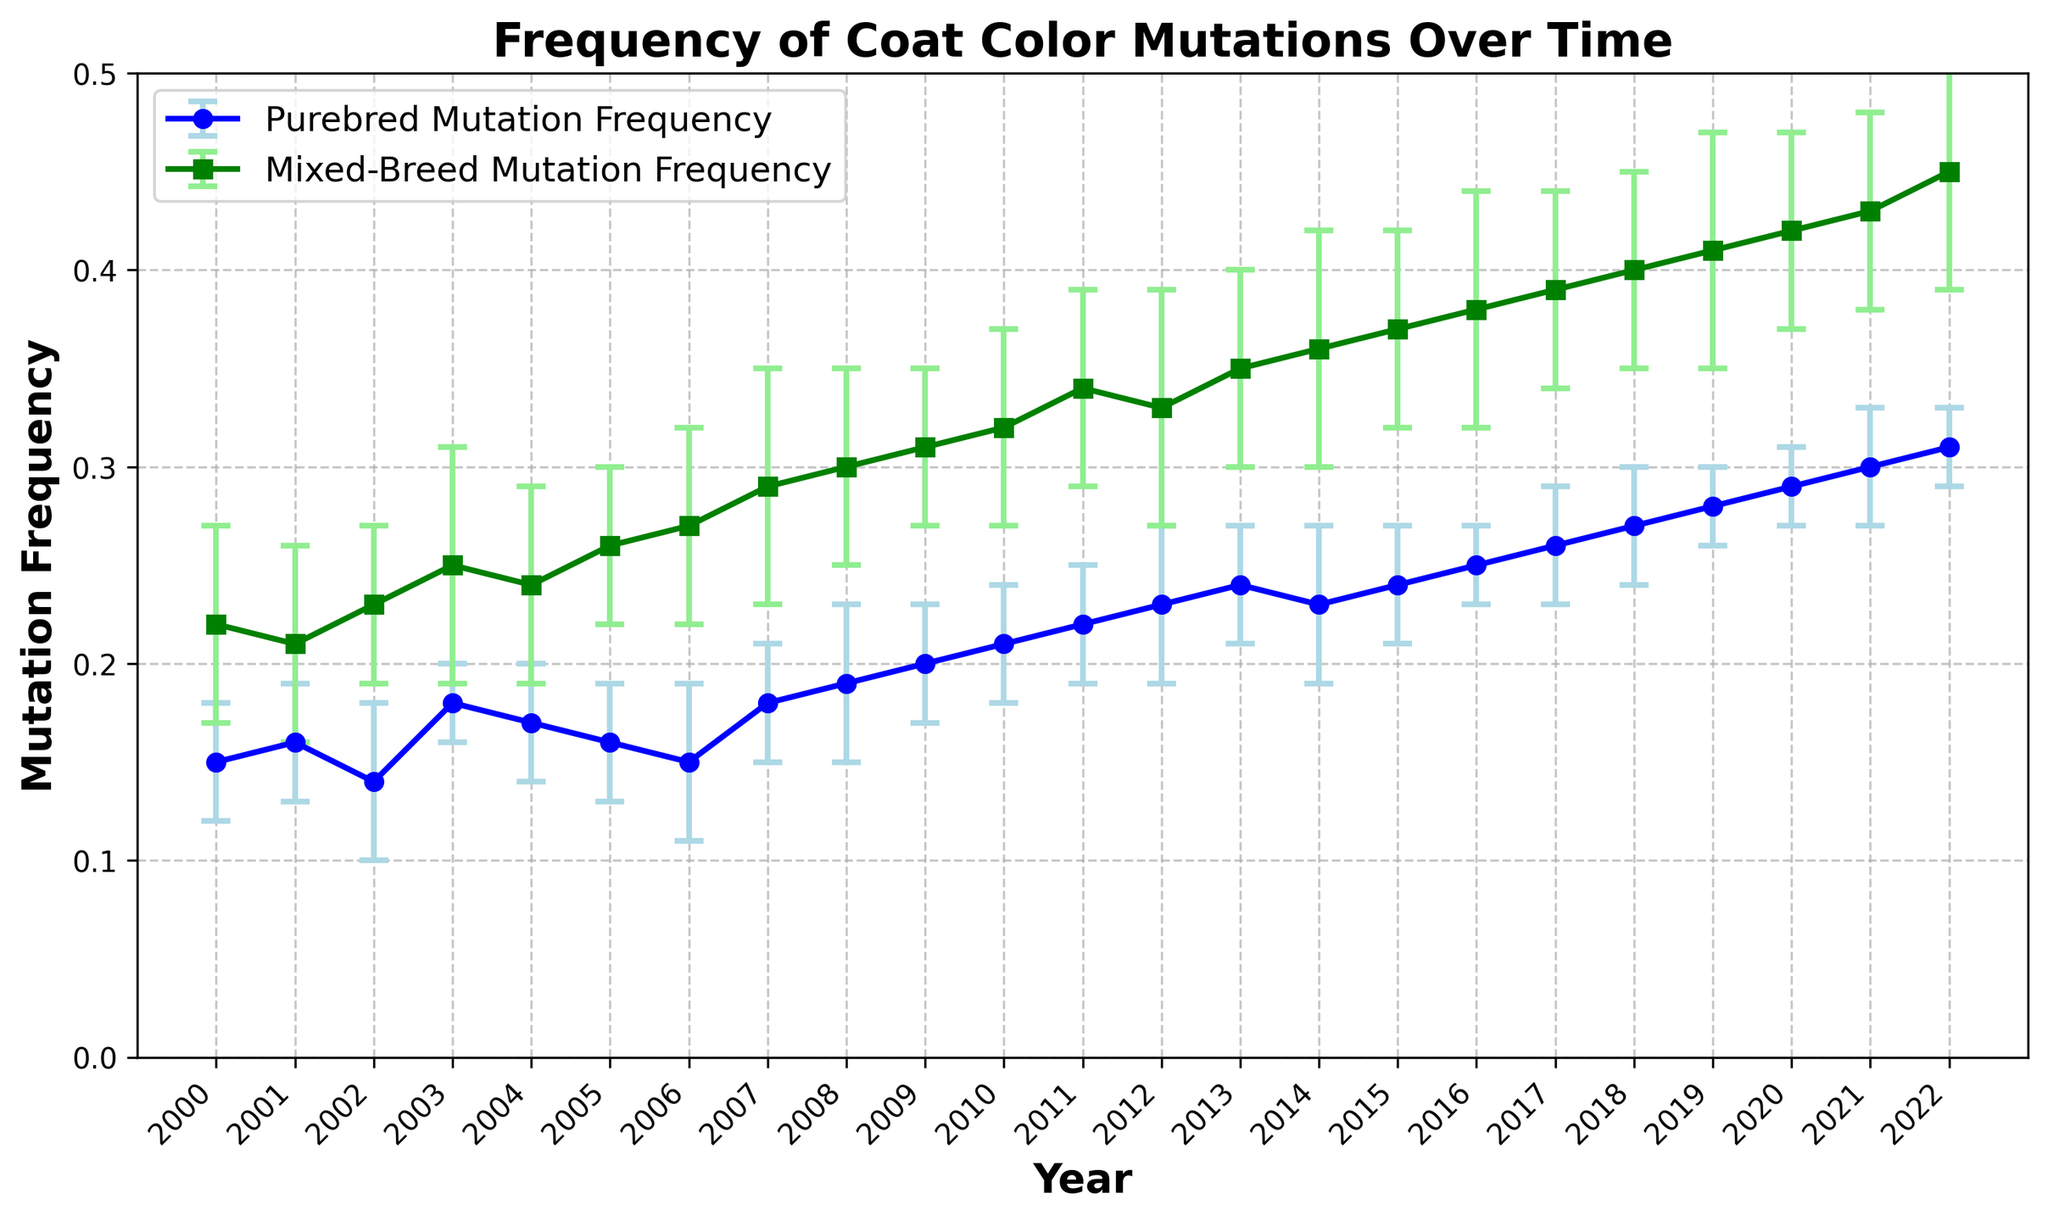What is the difference in mutation frequency between purebred and mixed-breed dogs in the year 2022? To find the difference, subtract the mutation frequency of purebred dogs from that of mixed-breed dogs in 2022: 0.45 - 0.31 = 0.14
Answer: 0.14 Which year shows the highest mutation frequency for purebred dogs, and what is that value? The year with the highest mutation frequency for purebred dogs can be found by examining the plot for the peak value of the blue line. In 2022, the frequency is the highest at 0.31
Answer: 2022, 0.31 How does the mutation frequency trend for mixed-breed dogs change from 2000 to 2022? By observing the green line in the plot, the mutation frequency for mixed-breed dogs shows a consistent increase from 0.22 in 2000 to 0.45 in 2022
Answer: It increases In which year do purebred and mixed-breed dogs have the smallest difference in mutation frequency, and what is the value of this difference? To determine this, calculate the absolute difference in mutation frequencies for each year and identify the smallest value: In 2009, the difference is smallest at 0.11 (0.31 - 0.20)
Answer: 2009, 0.11 What is the average mutation frequency for purebred dogs over the period from 2000 to 2022 rounded to 2 decimal places? To calculate the average:
(0.15 + 0.16 + 0.14 + 0.18 + 0.17 + 0.16 + 0.15 + 0.18 + 0.19 + 0.20 + 0.21 + 0.22 + 0.23 + 0.24 + 0.23 + 0.24 + 0.25 + 0.26 + 0.27 + 0.28 + 0.29 + 0.30 + 0.31) / 23 ≈ 0.21
Answer: 0.21 Compare the standard deviation of mutation frequency for purebred and mixed-breed dogs in 2003. Which one has lower variability? The standard deviation of mutation frequency for purebred dogs in 2003 is 0.02, and for mixed-breed dogs, it is 0.06. The smaller value indicates lower variability, so purebred dogs have lower variability in 2003
Answer: Purebred Between which consecutive years does the mutation frequency for mixed-breed dogs have the largest increase, and what is the value of that increase? By finding the differences between consecutive years and identifying the largest one: The largest increase is between 2021 and 2022, with an increase of 0.02 (0.45 - 0.43)
Answer: 2021 to 2022, 0.02 What is the overall trend in the standard deviation for mixed-breed dogs from 2000 to 2022? The green shades representing the error bars show relatively consistent heights over the years, indicating that the standard deviations do not change significantly, staying around 0.04-0.06
Answer: Relatively consistent Which year has the highest standard deviation for purebred dogs, and what is the value? By examining the plot and identifying the highest error bar for purebred dogs: The highest standard deviation is in 2002 and 2008 at 0.04
Answer: 2002, 2008, 0.04 